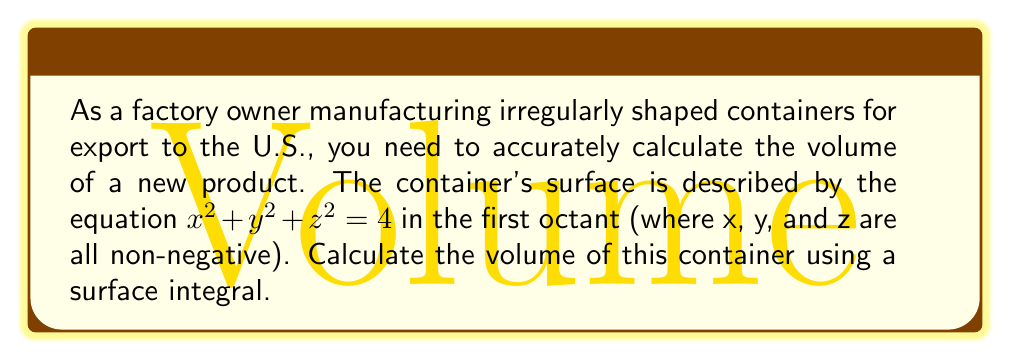Help me with this question. To calculate the volume of this irregularly shaped container using a surface integral, we'll follow these steps:

1) The surface is part of a sphere with radius 2, restricted to the first octant.

2) We'll use the divergence theorem, which states:
   $$\iiint_V \nabla \cdot \mathbf{F} \, dV = \iint_S \mathbf{F} \cdot \mathbf{n} \, dS$$
   where $\mathbf{F}$ is any vector field, $V$ is the volume, $S$ is the surface, and $\mathbf{n}$ is the outward unit normal vector.

3) Choose $\mathbf{F} = \frac{1}{3}(x, y, z)$. Then $\nabla \cdot \mathbf{F} = 1$.

4) The left side of the divergence theorem becomes the volume we're seeking:
   $$\iiint_V \nabla \cdot \mathbf{F} \, dV = \iiint_V 1 \, dV = \text{Volume}$$

5) For the right side, we need to calculate the surface integral over three parts:
   - The spherical part: $S_1: x^2 + y^2 + z^2 = 4$ in the first octant
   - The xy-plane part: $S_2: z = 0, 0 \leq x^2 + y^2 \leq 4$
   - The yz-plane part: $S_3: x = 0, 0 \leq y^2 + z^2 \leq 4$
   - The xz-plane part: $S_4: y = 0, 0 \leq x^2 + z^2 \leq 4$

6) For $S_1$, $\mathbf{n} = \frac{1}{2}(x, y, z)$, so:
   $$\iint_{S_1} \mathbf{F} \cdot \mathbf{n} \, dS = \frac{1}{6}\iint_{S_1} (x^2 + y^2 + z^2) \, dS = \frac{2}{3}\iint_{S_1} \, dS = \frac{2}{3} \cdot \frac{4\pi}{4} = \frac{\pi}{3}$$

7) For $S_2$, $\mathbf{n} = (0, 0, -1)$, so:
   $$\iint_{S_2} \mathbf{F} \cdot \mathbf{n} \, dS = -\frac{1}{3}\iint_{S_2} z \, dS = 0$$

8) Similarly, for $S_3$ and $S_4$:
   $$\iint_{S_3} \mathbf{F} \cdot \mathbf{n} \, dS = \iint_{S_4} \mathbf{F} \cdot \mathbf{n} \, dS = 0$$

9) The total surface integral is $\frac{\pi}{3}$, which equals the volume.
Answer: $\frac{\pi}{3}$ cubic units 